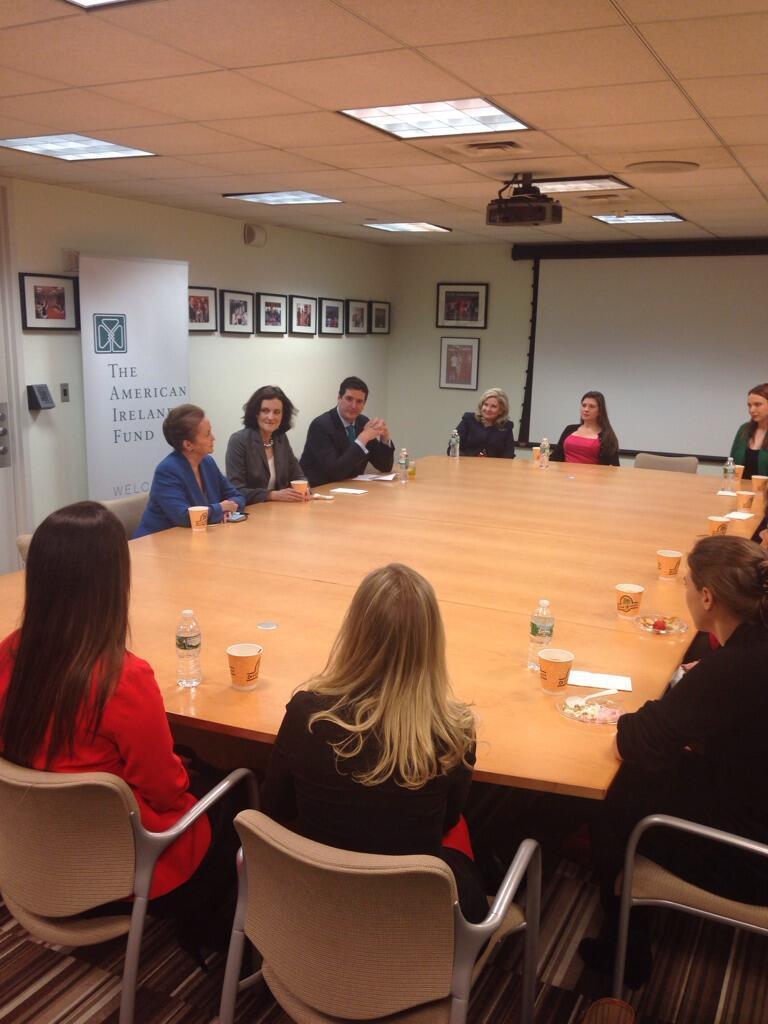Please provide a concise description of this image. There are many persons sitting on chairs around a table. On the table there are cups, bottles and some papers. In the background there is a wall. On the wall there is a screen, photo frames. A banner is over there. On the ceiling there are lights and projector. 